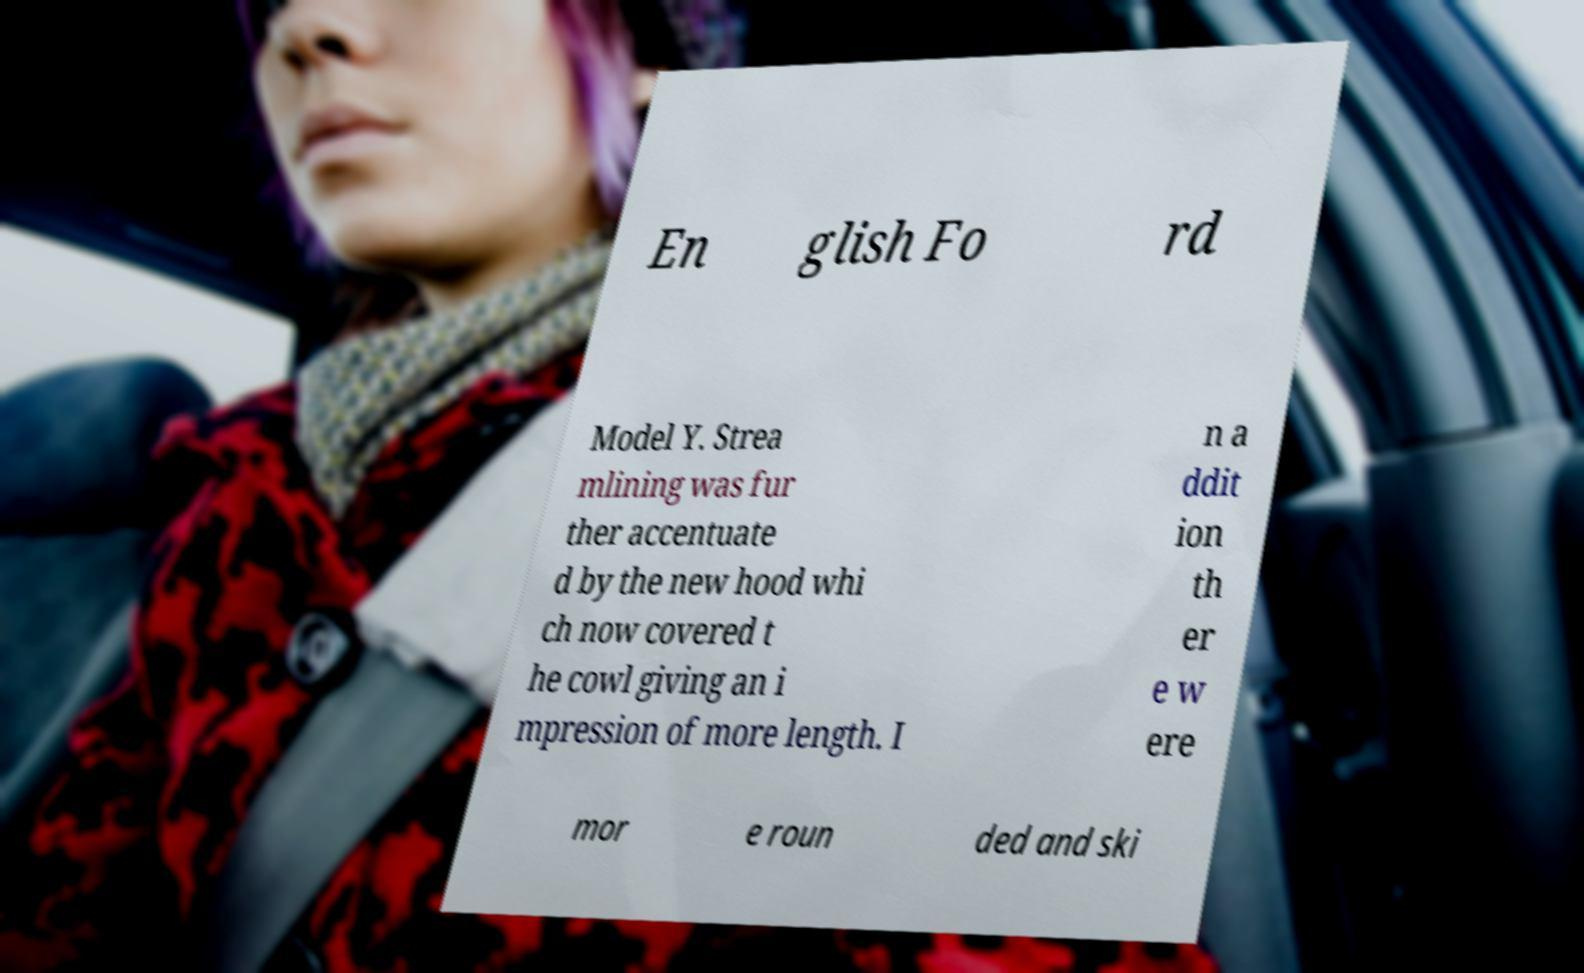Can you read and provide the text displayed in the image?This photo seems to have some interesting text. Can you extract and type it out for me? En glish Fo rd Model Y. Strea mlining was fur ther accentuate d by the new hood whi ch now covered t he cowl giving an i mpression of more length. I n a ddit ion th er e w ere mor e roun ded and ski 